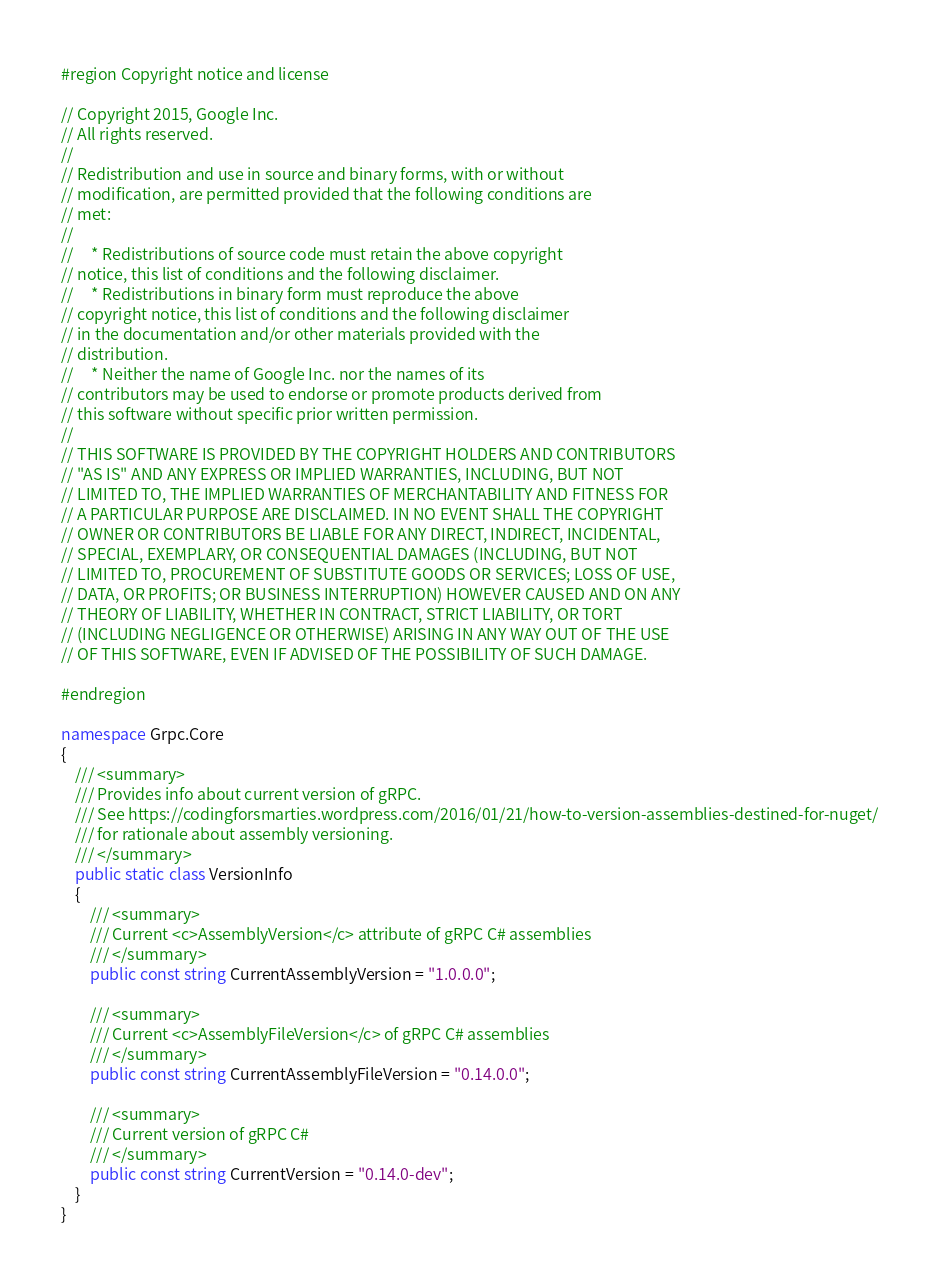<code> <loc_0><loc_0><loc_500><loc_500><_C#_>#region Copyright notice and license

// Copyright 2015, Google Inc.
// All rights reserved.
//
// Redistribution and use in source and binary forms, with or without
// modification, are permitted provided that the following conditions are
// met:
//
//     * Redistributions of source code must retain the above copyright
// notice, this list of conditions and the following disclaimer.
//     * Redistributions in binary form must reproduce the above
// copyright notice, this list of conditions and the following disclaimer
// in the documentation and/or other materials provided with the
// distribution.
//     * Neither the name of Google Inc. nor the names of its
// contributors may be used to endorse or promote products derived from
// this software without specific prior written permission.
//
// THIS SOFTWARE IS PROVIDED BY THE COPYRIGHT HOLDERS AND CONTRIBUTORS
// "AS IS" AND ANY EXPRESS OR IMPLIED WARRANTIES, INCLUDING, BUT NOT
// LIMITED TO, THE IMPLIED WARRANTIES OF MERCHANTABILITY AND FITNESS FOR
// A PARTICULAR PURPOSE ARE DISCLAIMED. IN NO EVENT SHALL THE COPYRIGHT
// OWNER OR CONTRIBUTORS BE LIABLE FOR ANY DIRECT, INDIRECT, INCIDENTAL,
// SPECIAL, EXEMPLARY, OR CONSEQUENTIAL DAMAGES (INCLUDING, BUT NOT
// LIMITED TO, PROCUREMENT OF SUBSTITUTE GOODS OR SERVICES; LOSS OF USE,
// DATA, OR PROFITS; OR BUSINESS INTERRUPTION) HOWEVER CAUSED AND ON ANY
// THEORY OF LIABILITY, WHETHER IN CONTRACT, STRICT LIABILITY, OR TORT
// (INCLUDING NEGLIGENCE OR OTHERWISE) ARISING IN ANY WAY OUT OF THE USE
// OF THIS SOFTWARE, EVEN IF ADVISED OF THE POSSIBILITY OF SUCH DAMAGE.

#endregion

namespace Grpc.Core
{
    /// <summary>
    /// Provides info about current version of gRPC.
    /// See https://codingforsmarties.wordpress.com/2016/01/21/how-to-version-assemblies-destined-for-nuget/
    /// for rationale about assembly versioning.
    /// </summary>
    public static class VersionInfo
    {
        /// <summary>
        /// Current <c>AssemblyVersion</c> attribute of gRPC C# assemblies
        /// </summary>
        public const string CurrentAssemblyVersion = "1.0.0.0";

        /// <summary>
        /// Current <c>AssemblyFileVersion</c> of gRPC C# assemblies
        /// </summary>
        public const string CurrentAssemblyFileVersion = "0.14.0.0";

        /// <summary>
        /// Current version of gRPC C#
        /// </summary>
        public const string CurrentVersion = "0.14.0-dev";
    }
}
</code> 